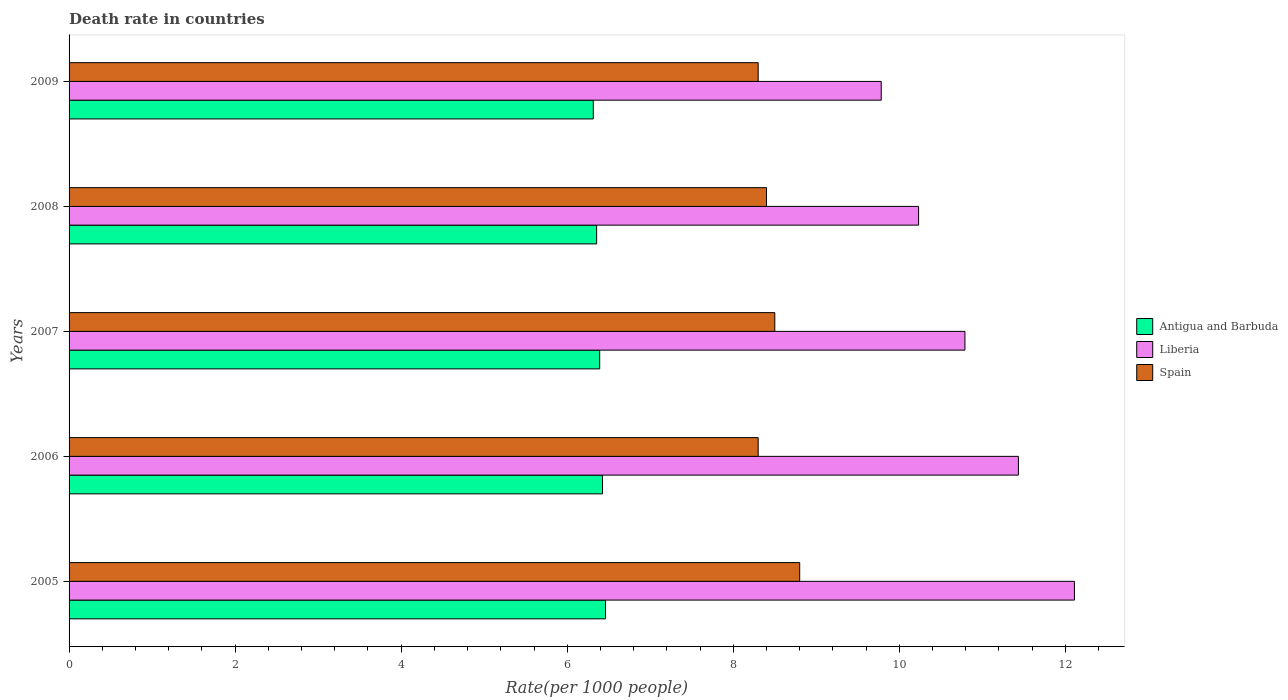How many different coloured bars are there?
Ensure brevity in your answer.  3. How many groups of bars are there?
Offer a very short reply. 5. Are the number of bars on each tick of the Y-axis equal?
Keep it short and to the point. Yes. How many bars are there on the 2nd tick from the bottom?
Keep it short and to the point. 3. What is the death rate in Liberia in 2007?
Give a very brief answer. 10.79. Across all years, what is the maximum death rate in Antigua and Barbuda?
Offer a very short reply. 6.46. Across all years, what is the minimum death rate in Antigua and Barbuda?
Your answer should be compact. 6.31. What is the total death rate in Liberia in the graph?
Give a very brief answer. 54.35. What is the difference between the death rate in Antigua and Barbuda in 2006 and that in 2007?
Give a very brief answer. 0.03. What is the difference between the death rate in Liberia in 2006 and the death rate in Antigua and Barbuda in 2005?
Give a very brief answer. 4.97. What is the average death rate in Antigua and Barbuda per year?
Ensure brevity in your answer.  6.39. In the year 2007, what is the difference between the death rate in Liberia and death rate in Antigua and Barbuda?
Your answer should be very brief. 4.4. In how many years, is the death rate in Antigua and Barbuda greater than 6 ?
Your answer should be very brief. 5. What is the ratio of the death rate in Antigua and Barbuda in 2007 to that in 2008?
Provide a succinct answer. 1.01. Is the death rate in Antigua and Barbuda in 2006 less than that in 2007?
Keep it short and to the point. No. What is the difference between the highest and the second highest death rate in Spain?
Make the answer very short. 0.3. What does the 3rd bar from the top in 2006 represents?
Ensure brevity in your answer.  Antigua and Barbuda. What does the 3rd bar from the bottom in 2007 represents?
Offer a very short reply. Spain. Is it the case that in every year, the sum of the death rate in Spain and death rate in Liberia is greater than the death rate in Antigua and Barbuda?
Offer a terse response. Yes. How many bars are there?
Ensure brevity in your answer.  15. Are the values on the major ticks of X-axis written in scientific E-notation?
Ensure brevity in your answer.  No. Does the graph contain grids?
Ensure brevity in your answer.  No. Where does the legend appear in the graph?
Give a very brief answer. Center right. How many legend labels are there?
Offer a very short reply. 3. How are the legend labels stacked?
Give a very brief answer. Vertical. What is the title of the graph?
Make the answer very short. Death rate in countries. Does "Luxembourg" appear as one of the legend labels in the graph?
Your answer should be very brief. No. What is the label or title of the X-axis?
Provide a short and direct response. Rate(per 1000 people). What is the label or title of the Y-axis?
Offer a very short reply. Years. What is the Rate(per 1000 people) in Antigua and Barbuda in 2005?
Make the answer very short. 6.46. What is the Rate(per 1000 people) of Liberia in 2005?
Ensure brevity in your answer.  12.11. What is the Rate(per 1000 people) in Antigua and Barbuda in 2006?
Ensure brevity in your answer.  6.42. What is the Rate(per 1000 people) in Liberia in 2006?
Keep it short and to the point. 11.43. What is the Rate(per 1000 people) in Spain in 2006?
Offer a very short reply. 8.3. What is the Rate(per 1000 people) in Antigua and Barbuda in 2007?
Keep it short and to the point. 6.39. What is the Rate(per 1000 people) in Liberia in 2007?
Provide a succinct answer. 10.79. What is the Rate(per 1000 people) in Antigua and Barbuda in 2008?
Keep it short and to the point. 6.35. What is the Rate(per 1000 people) in Liberia in 2008?
Your answer should be very brief. 10.23. What is the Rate(per 1000 people) in Antigua and Barbuda in 2009?
Your answer should be very brief. 6.31. What is the Rate(per 1000 people) in Liberia in 2009?
Ensure brevity in your answer.  9.78. What is the Rate(per 1000 people) of Spain in 2009?
Make the answer very short. 8.3. Across all years, what is the maximum Rate(per 1000 people) of Antigua and Barbuda?
Offer a very short reply. 6.46. Across all years, what is the maximum Rate(per 1000 people) of Liberia?
Offer a terse response. 12.11. Across all years, what is the maximum Rate(per 1000 people) in Spain?
Keep it short and to the point. 8.8. Across all years, what is the minimum Rate(per 1000 people) of Antigua and Barbuda?
Offer a terse response. 6.31. Across all years, what is the minimum Rate(per 1000 people) of Liberia?
Provide a short and direct response. 9.78. What is the total Rate(per 1000 people) of Antigua and Barbuda in the graph?
Offer a terse response. 31.95. What is the total Rate(per 1000 people) in Liberia in the graph?
Ensure brevity in your answer.  54.35. What is the total Rate(per 1000 people) of Spain in the graph?
Give a very brief answer. 42.3. What is the difference between the Rate(per 1000 people) in Antigua and Barbuda in 2005 and that in 2006?
Provide a short and direct response. 0.04. What is the difference between the Rate(per 1000 people) of Liberia in 2005 and that in 2006?
Make the answer very short. 0.68. What is the difference between the Rate(per 1000 people) in Spain in 2005 and that in 2006?
Provide a succinct answer. 0.5. What is the difference between the Rate(per 1000 people) of Antigua and Barbuda in 2005 and that in 2007?
Provide a succinct answer. 0.07. What is the difference between the Rate(per 1000 people) of Liberia in 2005 and that in 2007?
Make the answer very short. 1.32. What is the difference between the Rate(per 1000 people) in Spain in 2005 and that in 2007?
Your response must be concise. 0.3. What is the difference between the Rate(per 1000 people) of Antigua and Barbuda in 2005 and that in 2008?
Keep it short and to the point. 0.11. What is the difference between the Rate(per 1000 people) of Liberia in 2005 and that in 2008?
Your answer should be compact. 1.88. What is the difference between the Rate(per 1000 people) of Antigua and Barbuda in 2005 and that in 2009?
Your response must be concise. 0.15. What is the difference between the Rate(per 1000 people) in Liberia in 2005 and that in 2009?
Offer a very short reply. 2.33. What is the difference between the Rate(per 1000 people) of Spain in 2005 and that in 2009?
Offer a terse response. 0.5. What is the difference between the Rate(per 1000 people) of Antigua and Barbuda in 2006 and that in 2007?
Give a very brief answer. 0.03. What is the difference between the Rate(per 1000 people) of Liberia in 2006 and that in 2007?
Offer a terse response. 0.64. What is the difference between the Rate(per 1000 people) of Spain in 2006 and that in 2007?
Your response must be concise. -0.2. What is the difference between the Rate(per 1000 people) in Antigua and Barbuda in 2006 and that in 2008?
Make the answer very short. 0.07. What is the difference between the Rate(per 1000 people) in Liberia in 2006 and that in 2008?
Make the answer very short. 1.2. What is the difference between the Rate(per 1000 people) of Antigua and Barbuda in 2006 and that in 2009?
Give a very brief answer. 0.11. What is the difference between the Rate(per 1000 people) in Liberia in 2006 and that in 2009?
Your answer should be compact. 1.65. What is the difference between the Rate(per 1000 people) of Spain in 2006 and that in 2009?
Ensure brevity in your answer.  0. What is the difference between the Rate(per 1000 people) in Antigua and Barbuda in 2007 and that in 2008?
Offer a terse response. 0.04. What is the difference between the Rate(per 1000 people) in Liberia in 2007 and that in 2008?
Give a very brief answer. 0.56. What is the difference between the Rate(per 1000 people) in Antigua and Barbuda in 2007 and that in 2009?
Provide a succinct answer. 0.08. What is the difference between the Rate(per 1000 people) in Liberia in 2007 and that in 2009?
Your answer should be very brief. 1.01. What is the difference between the Rate(per 1000 people) in Spain in 2007 and that in 2009?
Offer a terse response. 0.2. What is the difference between the Rate(per 1000 people) in Antigua and Barbuda in 2008 and that in 2009?
Offer a terse response. 0.04. What is the difference between the Rate(per 1000 people) of Liberia in 2008 and that in 2009?
Provide a succinct answer. 0.45. What is the difference between the Rate(per 1000 people) in Spain in 2008 and that in 2009?
Give a very brief answer. 0.1. What is the difference between the Rate(per 1000 people) of Antigua and Barbuda in 2005 and the Rate(per 1000 people) of Liberia in 2006?
Your answer should be compact. -4.97. What is the difference between the Rate(per 1000 people) of Antigua and Barbuda in 2005 and the Rate(per 1000 people) of Spain in 2006?
Offer a terse response. -1.84. What is the difference between the Rate(per 1000 people) of Liberia in 2005 and the Rate(per 1000 people) of Spain in 2006?
Provide a succinct answer. 3.81. What is the difference between the Rate(per 1000 people) of Antigua and Barbuda in 2005 and the Rate(per 1000 people) of Liberia in 2007?
Give a very brief answer. -4.33. What is the difference between the Rate(per 1000 people) in Antigua and Barbuda in 2005 and the Rate(per 1000 people) in Spain in 2007?
Make the answer very short. -2.04. What is the difference between the Rate(per 1000 people) in Liberia in 2005 and the Rate(per 1000 people) in Spain in 2007?
Give a very brief answer. 3.61. What is the difference between the Rate(per 1000 people) in Antigua and Barbuda in 2005 and the Rate(per 1000 people) in Liberia in 2008?
Make the answer very short. -3.77. What is the difference between the Rate(per 1000 people) in Antigua and Barbuda in 2005 and the Rate(per 1000 people) in Spain in 2008?
Make the answer very short. -1.94. What is the difference between the Rate(per 1000 people) in Liberia in 2005 and the Rate(per 1000 people) in Spain in 2008?
Your response must be concise. 3.71. What is the difference between the Rate(per 1000 people) in Antigua and Barbuda in 2005 and the Rate(per 1000 people) in Liberia in 2009?
Give a very brief answer. -3.32. What is the difference between the Rate(per 1000 people) in Antigua and Barbuda in 2005 and the Rate(per 1000 people) in Spain in 2009?
Your answer should be compact. -1.84. What is the difference between the Rate(per 1000 people) of Liberia in 2005 and the Rate(per 1000 people) of Spain in 2009?
Your response must be concise. 3.81. What is the difference between the Rate(per 1000 people) in Antigua and Barbuda in 2006 and the Rate(per 1000 people) in Liberia in 2007?
Offer a very short reply. -4.37. What is the difference between the Rate(per 1000 people) in Antigua and Barbuda in 2006 and the Rate(per 1000 people) in Spain in 2007?
Offer a very short reply. -2.08. What is the difference between the Rate(per 1000 people) of Liberia in 2006 and the Rate(per 1000 people) of Spain in 2007?
Ensure brevity in your answer.  2.93. What is the difference between the Rate(per 1000 people) of Antigua and Barbuda in 2006 and the Rate(per 1000 people) of Liberia in 2008?
Ensure brevity in your answer.  -3.81. What is the difference between the Rate(per 1000 people) of Antigua and Barbuda in 2006 and the Rate(per 1000 people) of Spain in 2008?
Your answer should be compact. -1.98. What is the difference between the Rate(per 1000 people) of Liberia in 2006 and the Rate(per 1000 people) of Spain in 2008?
Provide a succinct answer. 3.03. What is the difference between the Rate(per 1000 people) in Antigua and Barbuda in 2006 and the Rate(per 1000 people) in Liberia in 2009?
Your answer should be compact. -3.36. What is the difference between the Rate(per 1000 people) in Antigua and Barbuda in 2006 and the Rate(per 1000 people) in Spain in 2009?
Give a very brief answer. -1.88. What is the difference between the Rate(per 1000 people) of Liberia in 2006 and the Rate(per 1000 people) of Spain in 2009?
Provide a short and direct response. 3.13. What is the difference between the Rate(per 1000 people) of Antigua and Barbuda in 2007 and the Rate(per 1000 people) of Liberia in 2008?
Offer a terse response. -3.84. What is the difference between the Rate(per 1000 people) in Antigua and Barbuda in 2007 and the Rate(per 1000 people) in Spain in 2008?
Keep it short and to the point. -2.01. What is the difference between the Rate(per 1000 people) in Liberia in 2007 and the Rate(per 1000 people) in Spain in 2008?
Offer a very short reply. 2.39. What is the difference between the Rate(per 1000 people) of Antigua and Barbuda in 2007 and the Rate(per 1000 people) of Liberia in 2009?
Give a very brief answer. -3.39. What is the difference between the Rate(per 1000 people) of Antigua and Barbuda in 2007 and the Rate(per 1000 people) of Spain in 2009?
Give a very brief answer. -1.91. What is the difference between the Rate(per 1000 people) in Liberia in 2007 and the Rate(per 1000 people) in Spain in 2009?
Make the answer very short. 2.49. What is the difference between the Rate(per 1000 people) in Antigua and Barbuda in 2008 and the Rate(per 1000 people) in Liberia in 2009?
Your response must be concise. -3.43. What is the difference between the Rate(per 1000 people) of Antigua and Barbuda in 2008 and the Rate(per 1000 people) of Spain in 2009?
Offer a terse response. -1.95. What is the difference between the Rate(per 1000 people) in Liberia in 2008 and the Rate(per 1000 people) in Spain in 2009?
Give a very brief answer. 1.93. What is the average Rate(per 1000 people) in Antigua and Barbuda per year?
Ensure brevity in your answer.  6.39. What is the average Rate(per 1000 people) of Liberia per year?
Your response must be concise. 10.87. What is the average Rate(per 1000 people) in Spain per year?
Offer a terse response. 8.46. In the year 2005, what is the difference between the Rate(per 1000 people) of Antigua and Barbuda and Rate(per 1000 people) of Liberia?
Your answer should be compact. -5.65. In the year 2005, what is the difference between the Rate(per 1000 people) in Antigua and Barbuda and Rate(per 1000 people) in Spain?
Your answer should be very brief. -2.34. In the year 2005, what is the difference between the Rate(per 1000 people) of Liberia and Rate(per 1000 people) of Spain?
Make the answer very short. 3.31. In the year 2006, what is the difference between the Rate(per 1000 people) of Antigua and Barbuda and Rate(per 1000 people) of Liberia?
Offer a terse response. -5.01. In the year 2006, what is the difference between the Rate(per 1000 people) in Antigua and Barbuda and Rate(per 1000 people) in Spain?
Keep it short and to the point. -1.88. In the year 2006, what is the difference between the Rate(per 1000 people) in Liberia and Rate(per 1000 people) in Spain?
Your response must be concise. 3.13. In the year 2007, what is the difference between the Rate(per 1000 people) in Antigua and Barbuda and Rate(per 1000 people) in Liberia?
Provide a succinct answer. -4.4. In the year 2007, what is the difference between the Rate(per 1000 people) of Antigua and Barbuda and Rate(per 1000 people) of Spain?
Give a very brief answer. -2.11. In the year 2007, what is the difference between the Rate(per 1000 people) in Liberia and Rate(per 1000 people) in Spain?
Provide a short and direct response. 2.29. In the year 2008, what is the difference between the Rate(per 1000 people) in Antigua and Barbuda and Rate(per 1000 people) in Liberia?
Provide a succinct answer. -3.88. In the year 2008, what is the difference between the Rate(per 1000 people) in Antigua and Barbuda and Rate(per 1000 people) in Spain?
Give a very brief answer. -2.05. In the year 2008, what is the difference between the Rate(per 1000 people) of Liberia and Rate(per 1000 people) of Spain?
Make the answer very short. 1.83. In the year 2009, what is the difference between the Rate(per 1000 people) of Antigua and Barbuda and Rate(per 1000 people) of Liberia?
Keep it short and to the point. -3.47. In the year 2009, what is the difference between the Rate(per 1000 people) of Antigua and Barbuda and Rate(per 1000 people) of Spain?
Offer a terse response. -1.99. In the year 2009, what is the difference between the Rate(per 1000 people) of Liberia and Rate(per 1000 people) of Spain?
Provide a succinct answer. 1.48. What is the ratio of the Rate(per 1000 people) of Antigua and Barbuda in 2005 to that in 2006?
Keep it short and to the point. 1.01. What is the ratio of the Rate(per 1000 people) in Liberia in 2005 to that in 2006?
Provide a succinct answer. 1.06. What is the ratio of the Rate(per 1000 people) in Spain in 2005 to that in 2006?
Give a very brief answer. 1.06. What is the ratio of the Rate(per 1000 people) of Liberia in 2005 to that in 2007?
Your response must be concise. 1.12. What is the ratio of the Rate(per 1000 people) in Spain in 2005 to that in 2007?
Keep it short and to the point. 1.04. What is the ratio of the Rate(per 1000 people) in Antigua and Barbuda in 2005 to that in 2008?
Your answer should be very brief. 1.02. What is the ratio of the Rate(per 1000 people) of Liberia in 2005 to that in 2008?
Your answer should be very brief. 1.18. What is the ratio of the Rate(per 1000 people) in Spain in 2005 to that in 2008?
Your response must be concise. 1.05. What is the ratio of the Rate(per 1000 people) in Antigua and Barbuda in 2005 to that in 2009?
Offer a terse response. 1.02. What is the ratio of the Rate(per 1000 people) in Liberia in 2005 to that in 2009?
Provide a succinct answer. 1.24. What is the ratio of the Rate(per 1000 people) of Spain in 2005 to that in 2009?
Your answer should be very brief. 1.06. What is the ratio of the Rate(per 1000 people) of Liberia in 2006 to that in 2007?
Offer a terse response. 1.06. What is the ratio of the Rate(per 1000 people) of Spain in 2006 to that in 2007?
Your response must be concise. 0.98. What is the ratio of the Rate(per 1000 people) in Antigua and Barbuda in 2006 to that in 2008?
Ensure brevity in your answer.  1.01. What is the ratio of the Rate(per 1000 people) of Liberia in 2006 to that in 2008?
Your response must be concise. 1.12. What is the ratio of the Rate(per 1000 people) of Antigua and Barbuda in 2006 to that in 2009?
Your response must be concise. 1.02. What is the ratio of the Rate(per 1000 people) in Liberia in 2006 to that in 2009?
Your answer should be very brief. 1.17. What is the ratio of the Rate(per 1000 people) in Liberia in 2007 to that in 2008?
Provide a succinct answer. 1.05. What is the ratio of the Rate(per 1000 people) in Spain in 2007 to that in 2008?
Give a very brief answer. 1.01. What is the ratio of the Rate(per 1000 people) of Antigua and Barbuda in 2007 to that in 2009?
Ensure brevity in your answer.  1.01. What is the ratio of the Rate(per 1000 people) of Liberia in 2007 to that in 2009?
Keep it short and to the point. 1.1. What is the ratio of the Rate(per 1000 people) in Spain in 2007 to that in 2009?
Ensure brevity in your answer.  1.02. What is the ratio of the Rate(per 1000 people) of Liberia in 2008 to that in 2009?
Ensure brevity in your answer.  1.05. What is the difference between the highest and the second highest Rate(per 1000 people) of Antigua and Barbuda?
Keep it short and to the point. 0.04. What is the difference between the highest and the second highest Rate(per 1000 people) in Liberia?
Keep it short and to the point. 0.68. What is the difference between the highest and the second highest Rate(per 1000 people) of Spain?
Your answer should be compact. 0.3. What is the difference between the highest and the lowest Rate(per 1000 people) in Antigua and Barbuda?
Provide a succinct answer. 0.15. What is the difference between the highest and the lowest Rate(per 1000 people) of Liberia?
Provide a short and direct response. 2.33. 